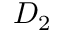<formula> <loc_0><loc_0><loc_500><loc_500>D _ { 2 }</formula> 